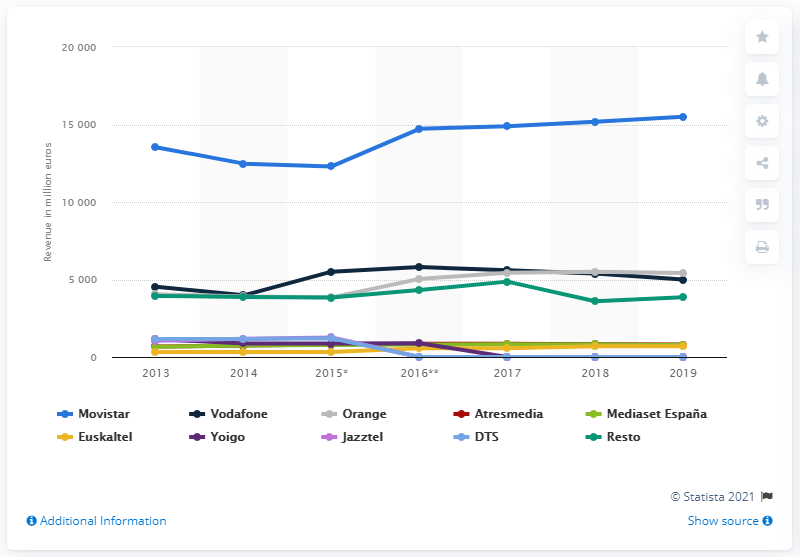Give some essential details in this illustration. According to data from 2019, Movistar was the telecommunications brand that generated the highest revenue in Spain. 